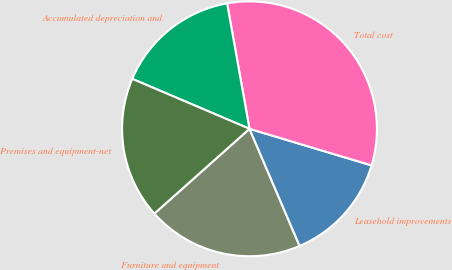<chart> <loc_0><loc_0><loc_500><loc_500><pie_chart><fcel>Furniture and equipment<fcel>Leasehold improvements<fcel>Total cost<fcel>Accumulated depreciation and<fcel>Premises and equipment-net<nl><fcel>19.85%<fcel>13.93%<fcel>32.45%<fcel>15.78%<fcel>18.0%<nl></chart> 